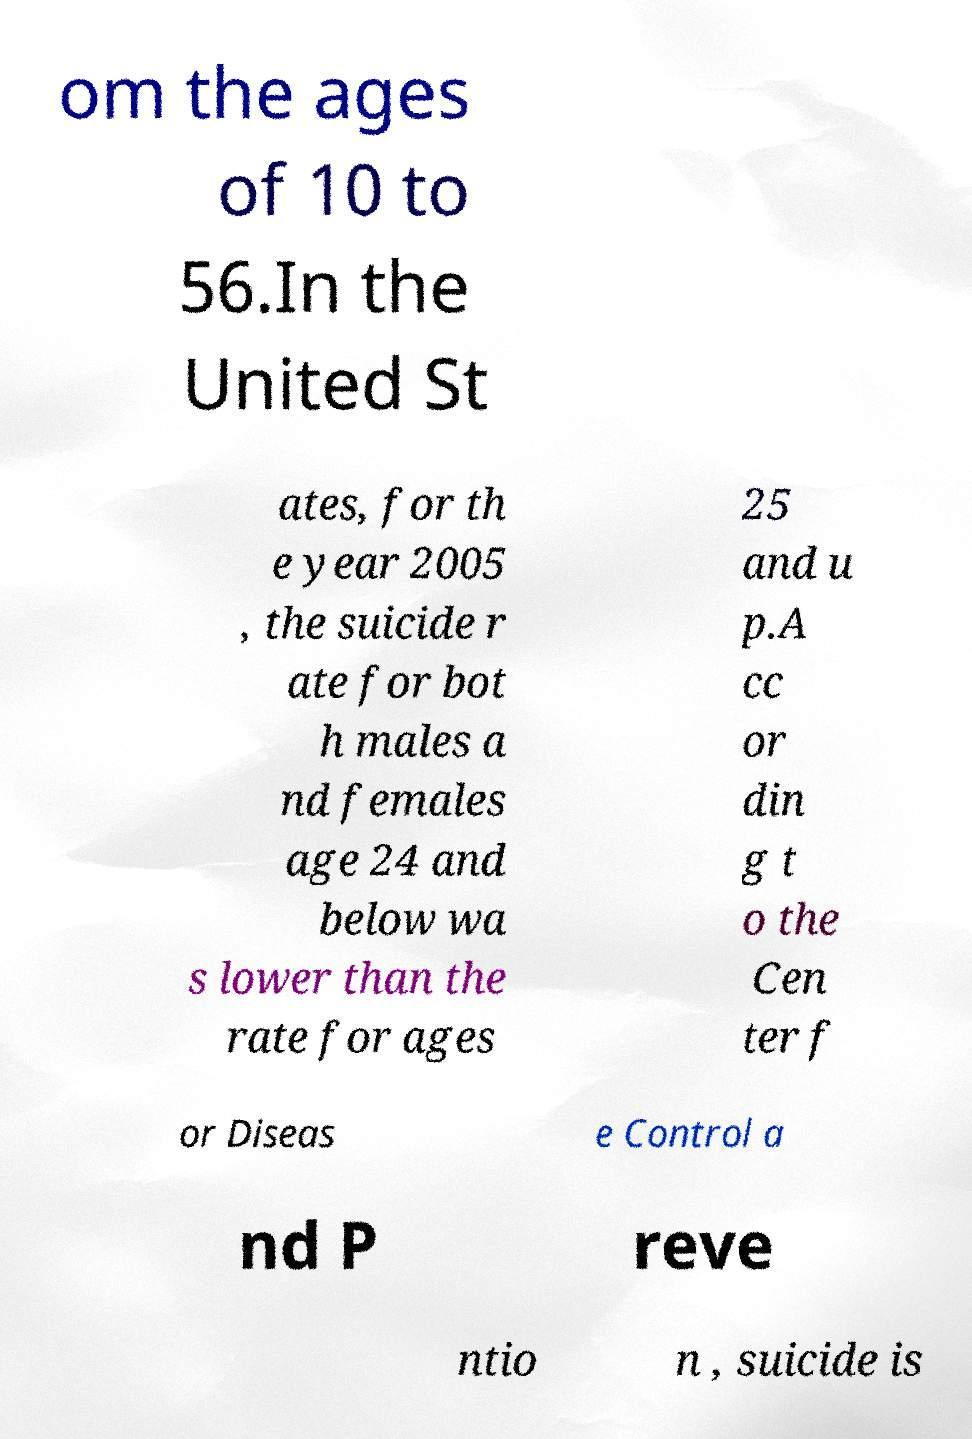Please read and relay the text visible in this image. What does it say? om the ages of 10 to 56.In the United St ates, for th e year 2005 , the suicide r ate for bot h males a nd females age 24 and below wa s lower than the rate for ages 25 and u p.A cc or din g t o the Cen ter f or Diseas e Control a nd P reve ntio n , suicide is 